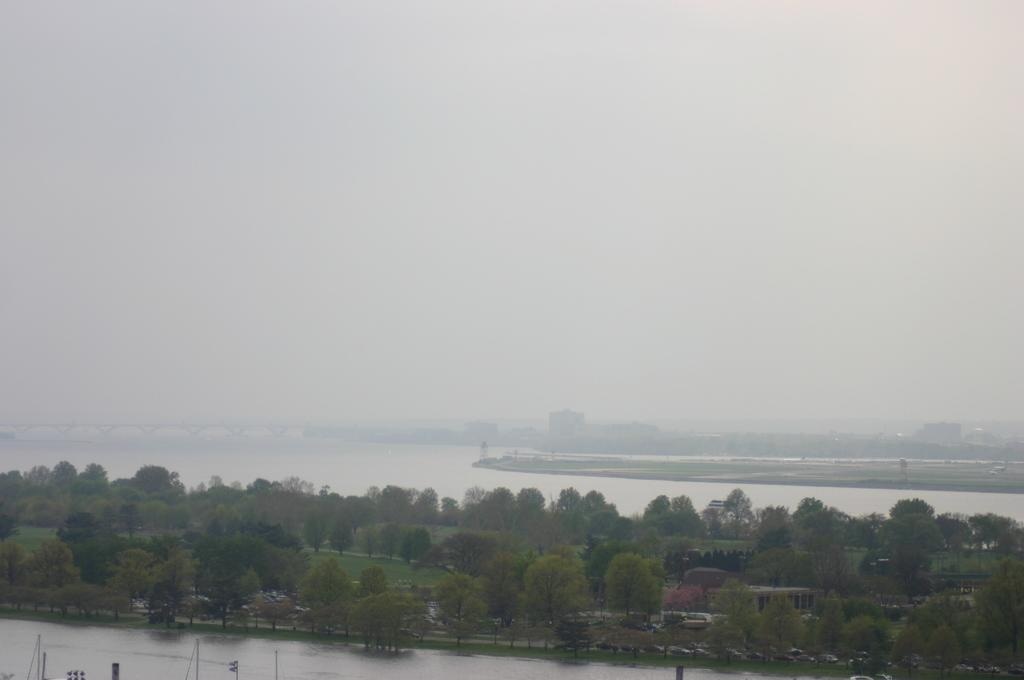What type of vegetation can be seen in the image? There are trees in the image. What natural element is visible alongside the trees? There is water visible in the image. What is visible above the trees and water? The sky is visible in the image. Reasoning: Let's think step by step by step in order to produce the conversation. We start by identifying the main subjects in the image, which are the trees. Then, we expand the conversation to include other elements that are also visible, such as water and the sky. Each question is designed to elicit a specific detail about the image that is known from the provided facts. Absurd Question/Answer: What type of thread is being used to sew the vessel in the image? There is no vessel or thread present in the image; it features trees, water, and the sky. What type of thread is being used to sew the vessel in the image? There is no vessel or thread present in the image; it features trees, water, and the sky. 